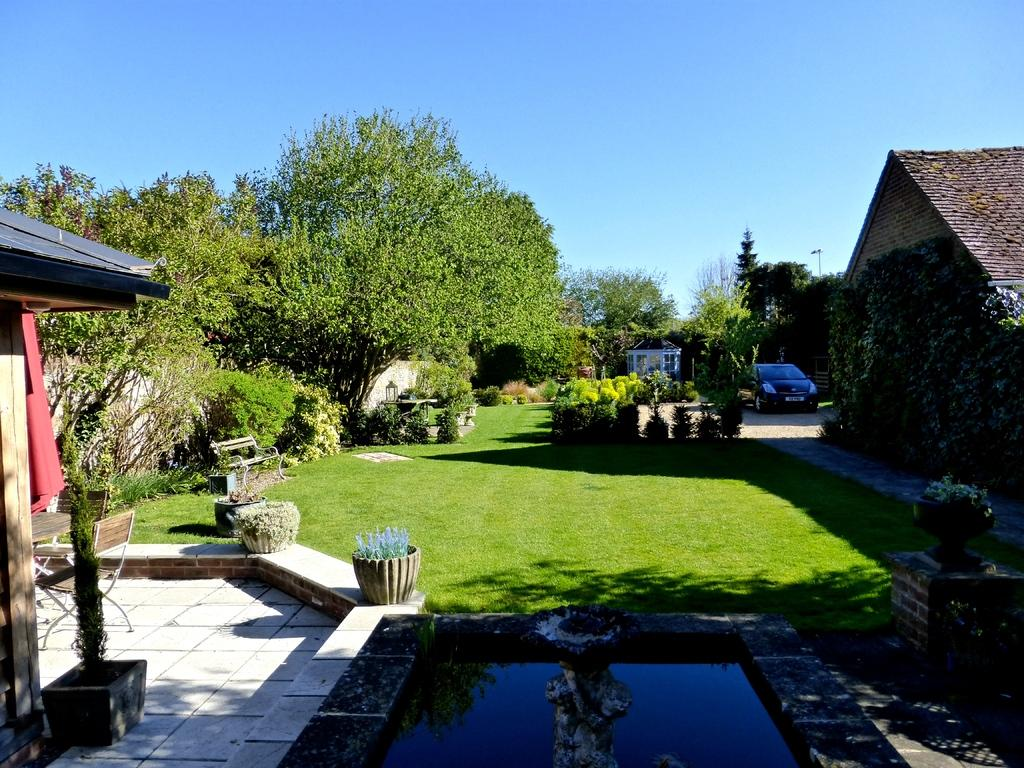What type of vehicle is in the image? The facts do not specify the type of vehicle. What type of seating is available in the image? There are chairs and a bench in the image. What type of surface is visible in the image? There is grass in the image. What type of vegetation is present in the image? There are plants, trees, and grass in the image. What type of structures are visible in the image? There are houses in the image. What type of liquid is visible in the image? There is water visible in the image. What type of natural environment is visible in the image? The sky is visible in the background of the image. How many brushes are used to paint the houses in the image? There is no information about brushes or painting in the image. How many men are visible in the image? There is no information about men in the image. 